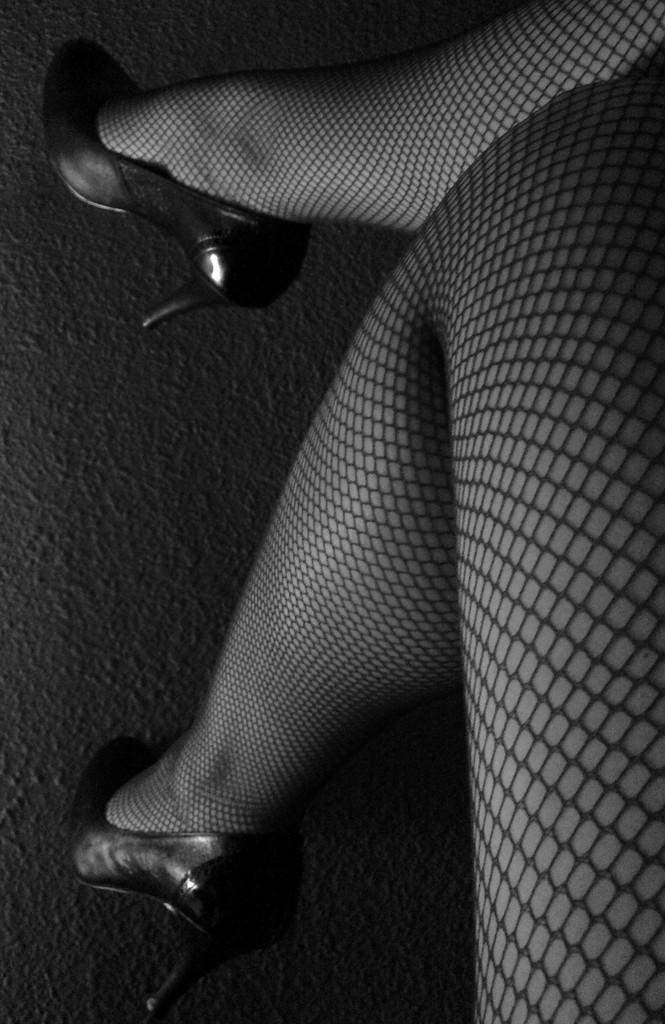What body parts of a person can be seen in the image? A person's legs are visible in the image. What is the person wearing on their legs? The person is wearing footwear on their legs. What type of surface is visible in the background of the image? There is a floor visible in the background of the image. What type of meal is being prepared on the person's legs in the image? There is no meal being prepared on the person's legs in the image; they are simply wearing footwear. What type of club can be seen in the person's hands in the image? There are no hands or clubs visible in the image; only the person's legs and footwear are present. 